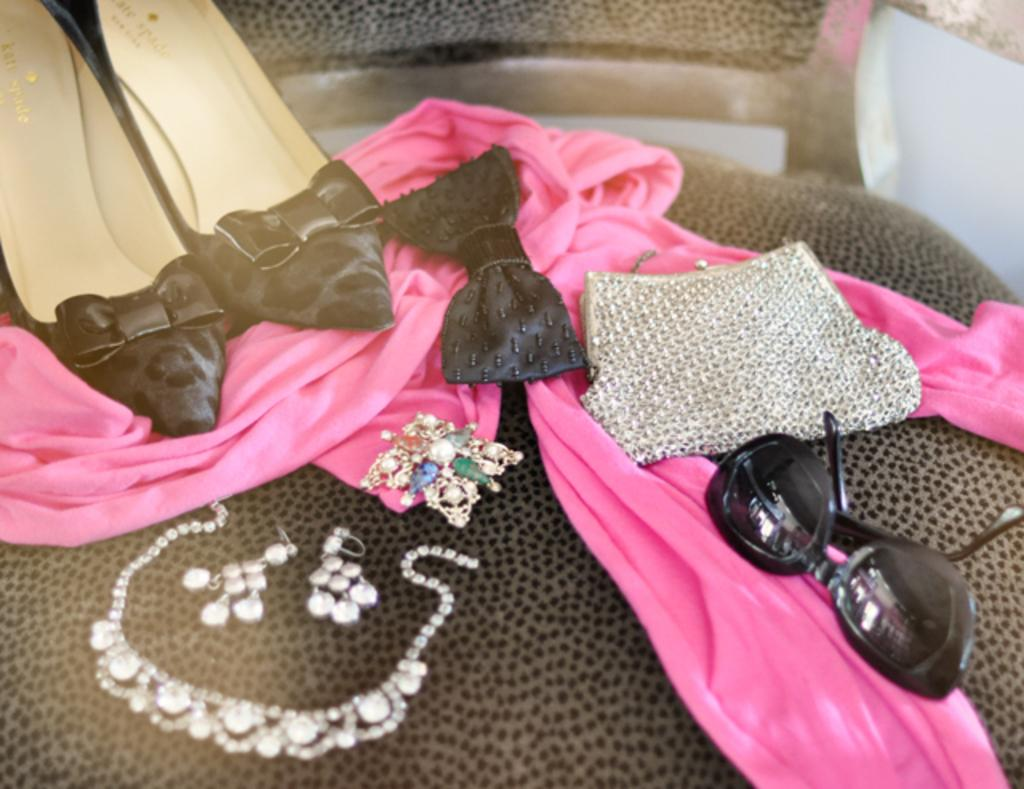What object is present in the image that people typically sit on? There is a chair in the image. What items can be found on the chair? The chair contains footwear, clothes, a bag, jewelry, and sunglasses. Can you describe the contents of the chair in more detail? The chair contains shoes, pants, a bag, a necklace, and sunglasses. What type of nail can be seen holding the chair together in the image? There is no nail visible in the image; the chair's construction is not described in the facts provided. 